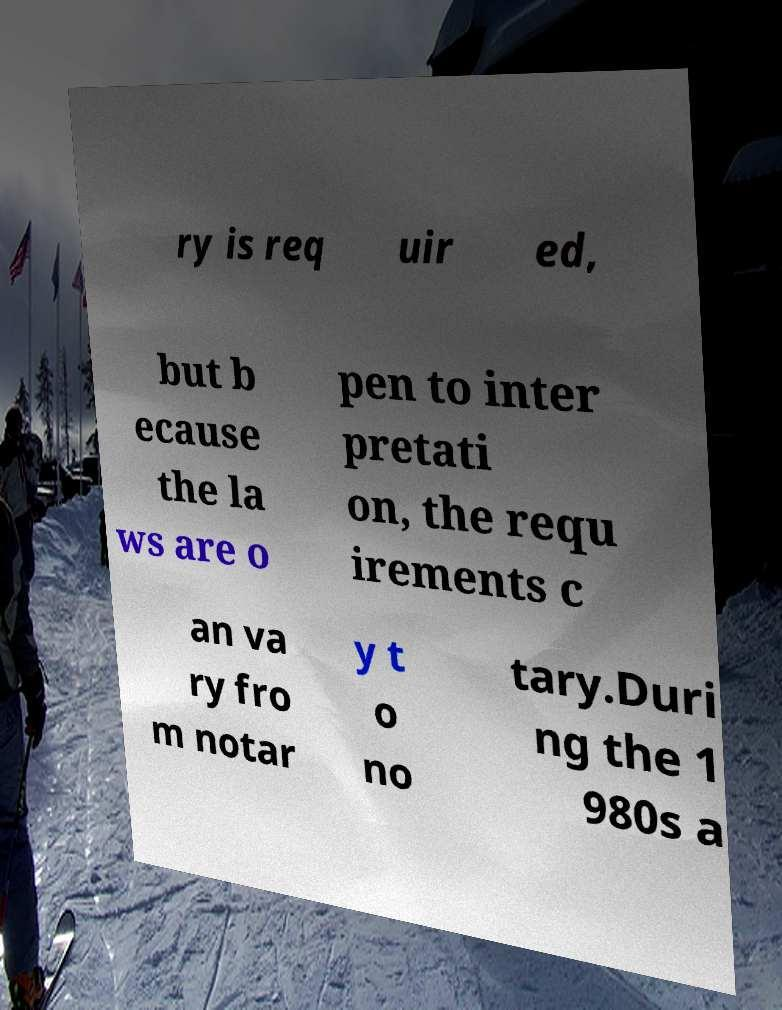For documentation purposes, I need the text within this image transcribed. Could you provide that? ry is req uir ed, but b ecause the la ws are o pen to inter pretati on, the requ irements c an va ry fro m notar y t o no tary.Duri ng the 1 980s a 